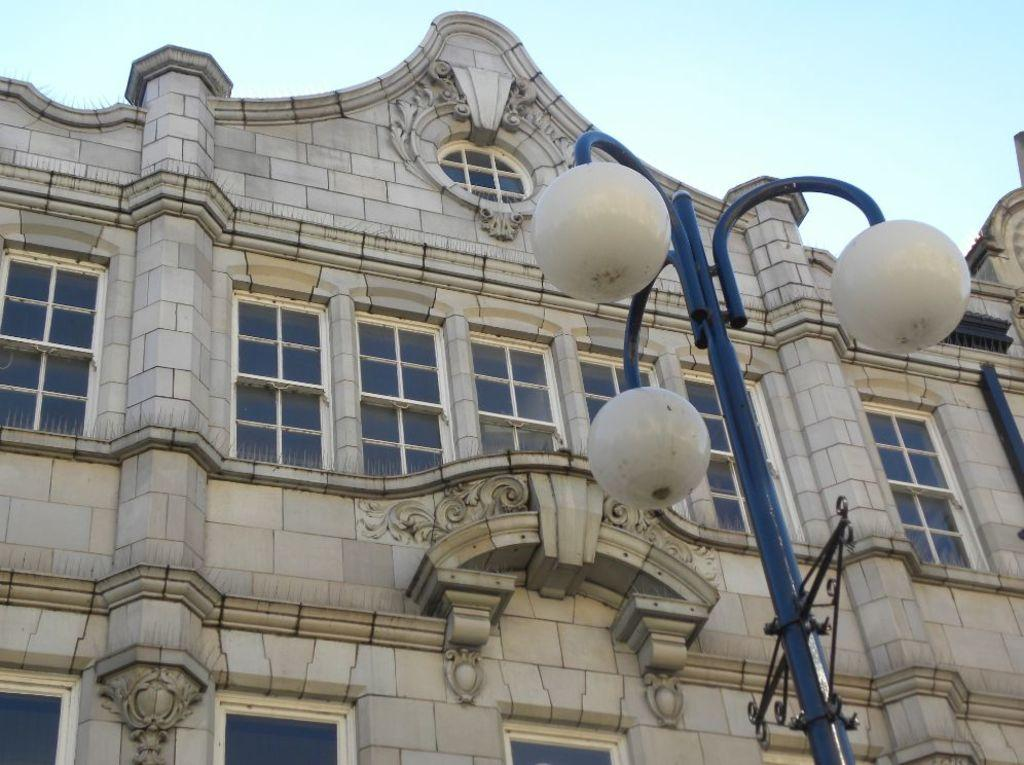What is the main structure in the center of the image? There is a building in the center of the image. What can be seen in the foreground of the image? There is a pole in the foreground of the image. What is attached to the pole? There are lights on the pole. What is visible at the top of the image? The sky is visible at the top of the image. What type of watch is the building wearing in the image? There is no watch present in the image, as buildings do not wear watches. 